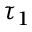Convert formula to latex. <formula><loc_0><loc_0><loc_500><loc_500>\tau _ { 1 }</formula> 